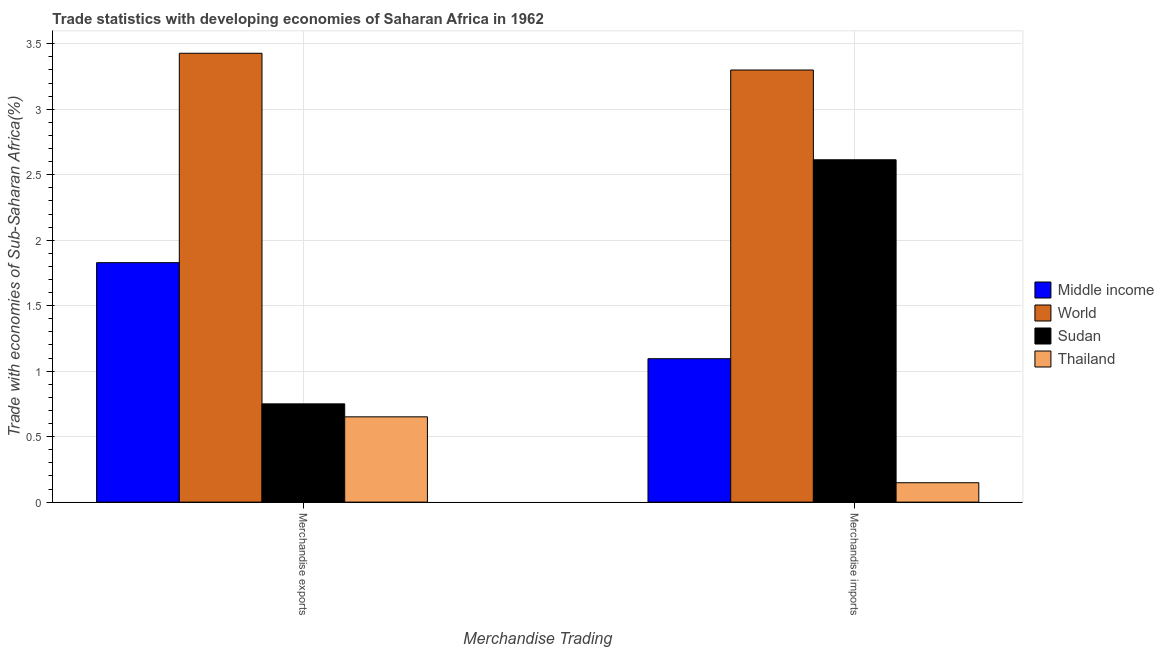How many bars are there on the 1st tick from the right?
Ensure brevity in your answer.  4. What is the label of the 1st group of bars from the left?
Offer a terse response. Merchandise exports. What is the merchandise exports in Thailand?
Your answer should be compact. 0.65. Across all countries, what is the maximum merchandise exports?
Give a very brief answer. 3.43. Across all countries, what is the minimum merchandise imports?
Your answer should be compact. 0.15. In which country was the merchandise imports maximum?
Give a very brief answer. World. In which country was the merchandise exports minimum?
Make the answer very short. Thailand. What is the total merchandise exports in the graph?
Make the answer very short. 6.66. What is the difference between the merchandise imports in Middle income and that in Thailand?
Provide a succinct answer. 0.95. What is the difference between the merchandise exports in Sudan and the merchandise imports in World?
Your answer should be very brief. -2.55. What is the average merchandise imports per country?
Your response must be concise. 1.79. What is the difference between the merchandise imports and merchandise exports in World?
Make the answer very short. -0.13. In how many countries, is the merchandise imports greater than 0.6 %?
Your response must be concise. 3. What is the ratio of the merchandise exports in World to that in Middle income?
Keep it short and to the point. 1.87. In how many countries, is the merchandise imports greater than the average merchandise imports taken over all countries?
Your answer should be compact. 2. What does the 3rd bar from the left in Merchandise exports represents?
Give a very brief answer. Sudan. How many bars are there?
Ensure brevity in your answer.  8. Are all the bars in the graph horizontal?
Ensure brevity in your answer.  No. How many countries are there in the graph?
Offer a terse response. 4. Does the graph contain grids?
Offer a very short reply. Yes. Where does the legend appear in the graph?
Provide a short and direct response. Center right. How are the legend labels stacked?
Provide a succinct answer. Vertical. What is the title of the graph?
Ensure brevity in your answer.  Trade statistics with developing economies of Saharan Africa in 1962. Does "Malawi" appear as one of the legend labels in the graph?
Ensure brevity in your answer.  No. What is the label or title of the X-axis?
Your response must be concise. Merchandise Trading. What is the label or title of the Y-axis?
Provide a short and direct response. Trade with economies of Sub-Saharan Africa(%). What is the Trade with economies of Sub-Saharan Africa(%) of Middle income in Merchandise exports?
Your answer should be very brief. 1.83. What is the Trade with economies of Sub-Saharan Africa(%) in World in Merchandise exports?
Keep it short and to the point. 3.43. What is the Trade with economies of Sub-Saharan Africa(%) of Sudan in Merchandise exports?
Give a very brief answer. 0.75. What is the Trade with economies of Sub-Saharan Africa(%) in Thailand in Merchandise exports?
Keep it short and to the point. 0.65. What is the Trade with economies of Sub-Saharan Africa(%) of Middle income in Merchandise imports?
Your answer should be very brief. 1.1. What is the Trade with economies of Sub-Saharan Africa(%) in World in Merchandise imports?
Your answer should be compact. 3.3. What is the Trade with economies of Sub-Saharan Africa(%) of Sudan in Merchandise imports?
Ensure brevity in your answer.  2.61. What is the Trade with economies of Sub-Saharan Africa(%) of Thailand in Merchandise imports?
Make the answer very short. 0.15. Across all Merchandise Trading, what is the maximum Trade with economies of Sub-Saharan Africa(%) of Middle income?
Provide a short and direct response. 1.83. Across all Merchandise Trading, what is the maximum Trade with economies of Sub-Saharan Africa(%) of World?
Make the answer very short. 3.43. Across all Merchandise Trading, what is the maximum Trade with economies of Sub-Saharan Africa(%) of Sudan?
Offer a very short reply. 2.61. Across all Merchandise Trading, what is the maximum Trade with economies of Sub-Saharan Africa(%) in Thailand?
Offer a very short reply. 0.65. Across all Merchandise Trading, what is the minimum Trade with economies of Sub-Saharan Africa(%) in Middle income?
Make the answer very short. 1.1. Across all Merchandise Trading, what is the minimum Trade with economies of Sub-Saharan Africa(%) in World?
Your response must be concise. 3.3. Across all Merchandise Trading, what is the minimum Trade with economies of Sub-Saharan Africa(%) in Sudan?
Offer a terse response. 0.75. Across all Merchandise Trading, what is the minimum Trade with economies of Sub-Saharan Africa(%) of Thailand?
Offer a very short reply. 0.15. What is the total Trade with economies of Sub-Saharan Africa(%) of Middle income in the graph?
Ensure brevity in your answer.  2.92. What is the total Trade with economies of Sub-Saharan Africa(%) in World in the graph?
Give a very brief answer. 6.73. What is the total Trade with economies of Sub-Saharan Africa(%) of Sudan in the graph?
Provide a short and direct response. 3.36. What is the total Trade with economies of Sub-Saharan Africa(%) of Thailand in the graph?
Provide a short and direct response. 0.8. What is the difference between the Trade with economies of Sub-Saharan Africa(%) of Middle income in Merchandise exports and that in Merchandise imports?
Offer a very short reply. 0.73. What is the difference between the Trade with economies of Sub-Saharan Africa(%) of World in Merchandise exports and that in Merchandise imports?
Ensure brevity in your answer.  0.13. What is the difference between the Trade with economies of Sub-Saharan Africa(%) of Sudan in Merchandise exports and that in Merchandise imports?
Offer a terse response. -1.86. What is the difference between the Trade with economies of Sub-Saharan Africa(%) of Thailand in Merchandise exports and that in Merchandise imports?
Keep it short and to the point. 0.5. What is the difference between the Trade with economies of Sub-Saharan Africa(%) in Middle income in Merchandise exports and the Trade with economies of Sub-Saharan Africa(%) in World in Merchandise imports?
Offer a very short reply. -1.47. What is the difference between the Trade with economies of Sub-Saharan Africa(%) in Middle income in Merchandise exports and the Trade with economies of Sub-Saharan Africa(%) in Sudan in Merchandise imports?
Keep it short and to the point. -0.79. What is the difference between the Trade with economies of Sub-Saharan Africa(%) in Middle income in Merchandise exports and the Trade with economies of Sub-Saharan Africa(%) in Thailand in Merchandise imports?
Your response must be concise. 1.68. What is the difference between the Trade with economies of Sub-Saharan Africa(%) in World in Merchandise exports and the Trade with economies of Sub-Saharan Africa(%) in Sudan in Merchandise imports?
Give a very brief answer. 0.81. What is the difference between the Trade with economies of Sub-Saharan Africa(%) of World in Merchandise exports and the Trade with economies of Sub-Saharan Africa(%) of Thailand in Merchandise imports?
Make the answer very short. 3.28. What is the difference between the Trade with economies of Sub-Saharan Africa(%) in Sudan in Merchandise exports and the Trade with economies of Sub-Saharan Africa(%) in Thailand in Merchandise imports?
Offer a very short reply. 0.6. What is the average Trade with economies of Sub-Saharan Africa(%) of Middle income per Merchandise Trading?
Your response must be concise. 1.46. What is the average Trade with economies of Sub-Saharan Africa(%) of World per Merchandise Trading?
Offer a very short reply. 3.36. What is the average Trade with economies of Sub-Saharan Africa(%) of Sudan per Merchandise Trading?
Keep it short and to the point. 1.68. What is the average Trade with economies of Sub-Saharan Africa(%) in Thailand per Merchandise Trading?
Keep it short and to the point. 0.4. What is the difference between the Trade with economies of Sub-Saharan Africa(%) in Middle income and Trade with economies of Sub-Saharan Africa(%) in World in Merchandise exports?
Provide a succinct answer. -1.6. What is the difference between the Trade with economies of Sub-Saharan Africa(%) in Middle income and Trade with economies of Sub-Saharan Africa(%) in Sudan in Merchandise exports?
Provide a succinct answer. 1.08. What is the difference between the Trade with economies of Sub-Saharan Africa(%) of Middle income and Trade with economies of Sub-Saharan Africa(%) of Thailand in Merchandise exports?
Your response must be concise. 1.18. What is the difference between the Trade with economies of Sub-Saharan Africa(%) of World and Trade with economies of Sub-Saharan Africa(%) of Sudan in Merchandise exports?
Make the answer very short. 2.68. What is the difference between the Trade with economies of Sub-Saharan Africa(%) of World and Trade with economies of Sub-Saharan Africa(%) of Thailand in Merchandise exports?
Your answer should be very brief. 2.78. What is the difference between the Trade with economies of Sub-Saharan Africa(%) in Sudan and Trade with economies of Sub-Saharan Africa(%) in Thailand in Merchandise exports?
Offer a very short reply. 0.1. What is the difference between the Trade with economies of Sub-Saharan Africa(%) in Middle income and Trade with economies of Sub-Saharan Africa(%) in World in Merchandise imports?
Provide a short and direct response. -2.2. What is the difference between the Trade with economies of Sub-Saharan Africa(%) of Middle income and Trade with economies of Sub-Saharan Africa(%) of Sudan in Merchandise imports?
Your response must be concise. -1.52. What is the difference between the Trade with economies of Sub-Saharan Africa(%) of Middle income and Trade with economies of Sub-Saharan Africa(%) of Thailand in Merchandise imports?
Make the answer very short. 0.95. What is the difference between the Trade with economies of Sub-Saharan Africa(%) in World and Trade with economies of Sub-Saharan Africa(%) in Sudan in Merchandise imports?
Make the answer very short. 0.69. What is the difference between the Trade with economies of Sub-Saharan Africa(%) in World and Trade with economies of Sub-Saharan Africa(%) in Thailand in Merchandise imports?
Give a very brief answer. 3.15. What is the difference between the Trade with economies of Sub-Saharan Africa(%) of Sudan and Trade with economies of Sub-Saharan Africa(%) of Thailand in Merchandise imports?
Offer a terse response. 2.47. What is the ratio of the Trade with economies of Sub-Saharan Africa(%) in Middle income in Merchandise exports to that in Merchandise imports?
Your response must be concise. 1.67. What is the ratio of the Trade with economies of Sub-Saharan Africa(%) in World in Merchandise exports to that in Merchandise imports?
Your answer should be very brief. 1.04. What is the ratio of the Trade with economies of Sub-Saharan Africa(%) in Sudan in Merchandise exports to that in Merchandise imports?
Make the answer very short. 0.29. What is the ratio of the Trade with economies of Sub-Saharan Africa(%) of Thailand in Merchandise exports to that in Merchandise imports?
Ensure brevity in your answer.  4.4. What is the difference between the highest and the second highest Trade with economies of Sub-Saharan Africa(%) in Middle income?
Offer a very short reply. 0.73. What is the difference between the highest and the second highest Trade with economies of Sub-Saharan Africa(%) of World?
Your answer should be compact. 0.13. What is the difference between the highest and the second highest Trade with economies of Sub-Saharan Africa(%) in Sudan?
Your response must be concise. 1.86. What is the difference between the highest and the second highest Trade with economies of Sub-Saharan Africa(%) in Thailand?
Your answer should be very brief. 0.5. What is the difference between the highest and the lowest Trade with economies of Sub-Saharan Africa(%) in Middle income?
Keep it short and to the point. 0.73. What is the difference between the highest and the lowest Trade with economies of Sub-Saharan Africa(%) of World?
Offer a very short reply. 0.13. What is the difference between the highest and the lowest Trade with economies of Sub-Saharan Africa(%) of Sudan?
Make the answer very short. 1.86. What is the difference between the highest and the lowest Trade with economies of Sub-Saharan Africa(%) in Thailand?
Your response must be concise. 0.5. 